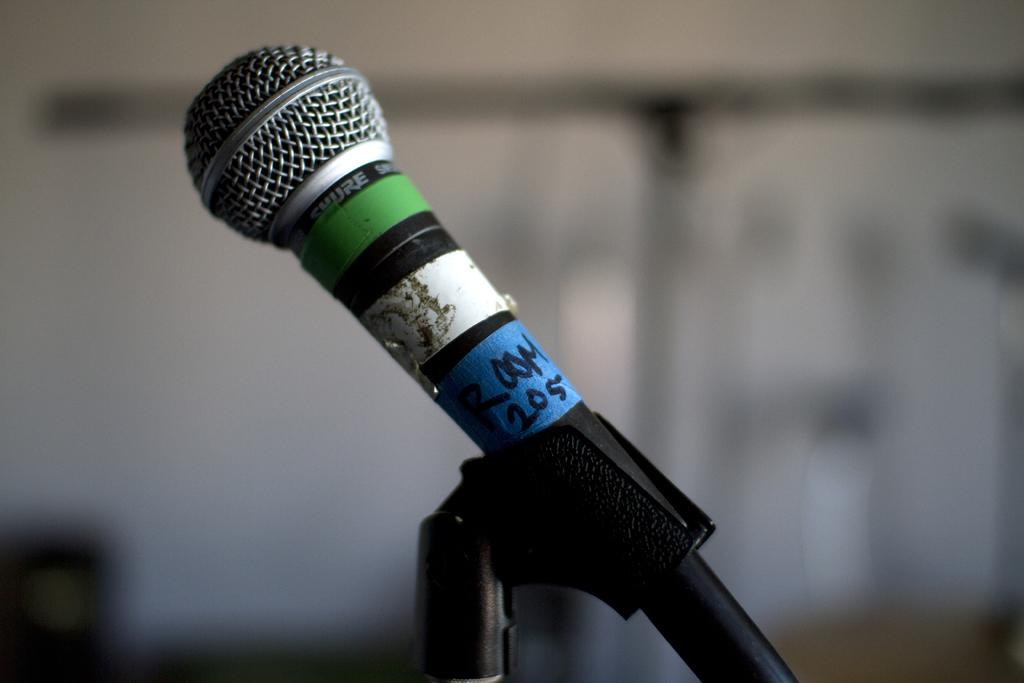What object is the main focus of the image? There is a microphone in the image. How is the microphone positioned in the image? The microphone is attached to a stand. Can you describe the background of the image? The background of the image is blurred. What type of hospital equipment can be seen in the image? There is no hospital equipment present in the image; it features a microphone attached to a stand. Can you see a tramp in the image? There is no tramp present in the image. 